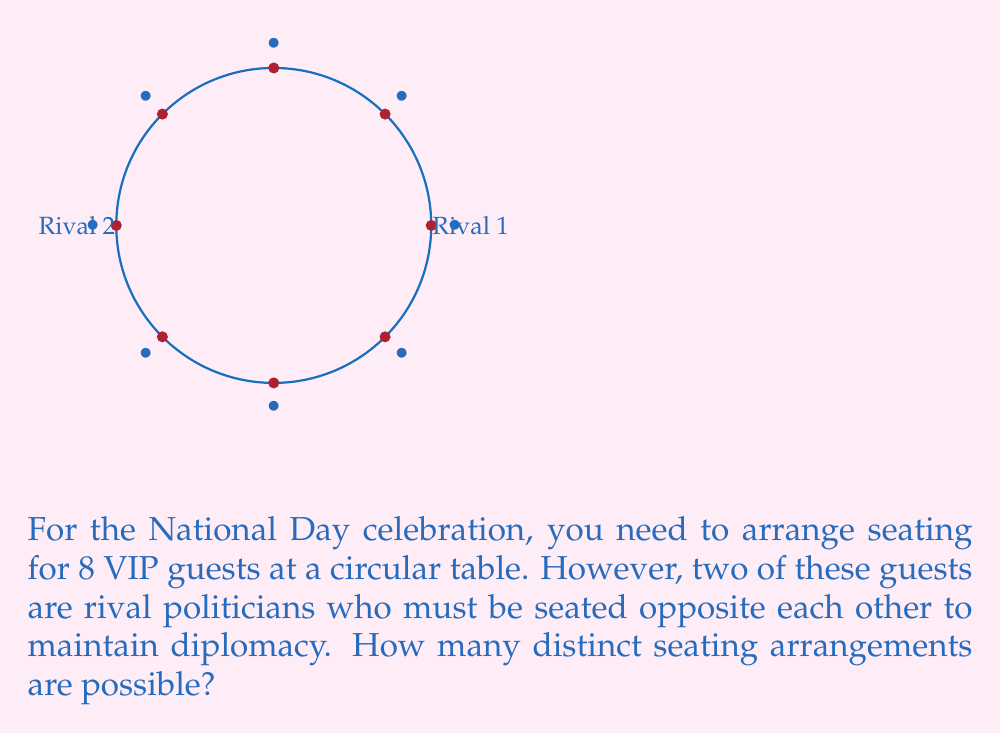What is the answer to this math problem? Let's approach this step-by-step:

1) First, consider the two rival politicians. They must be seated opposite each other, which means their positions are fixed once we choose a seat for one of them. This effectively reduces our problem to arranging 7 people (1 rival + 6 others).

2) For a circular table, rotations of the same arrangement are considered identical. This means we can fix the position of one person (let's say Rival 1) and arrange the rest.

3) Now we have 6 people to arrange in the remaining 6 seats (Rival 2's position is determined by Rival 1's).

4) This is a straightforward permutation problem. The number of ways to arrange 6 people in 6 seats is given by $6!$.

5) Therefore, the number of distinct seating arrangements is:

   $$6! = 6 \times 5 \times 4 \times 3 \times 2 \times 1 = 720$$

Thus, there are 720 possible seating arrangements that satisfy the given conditions.
Answer: $720$ 